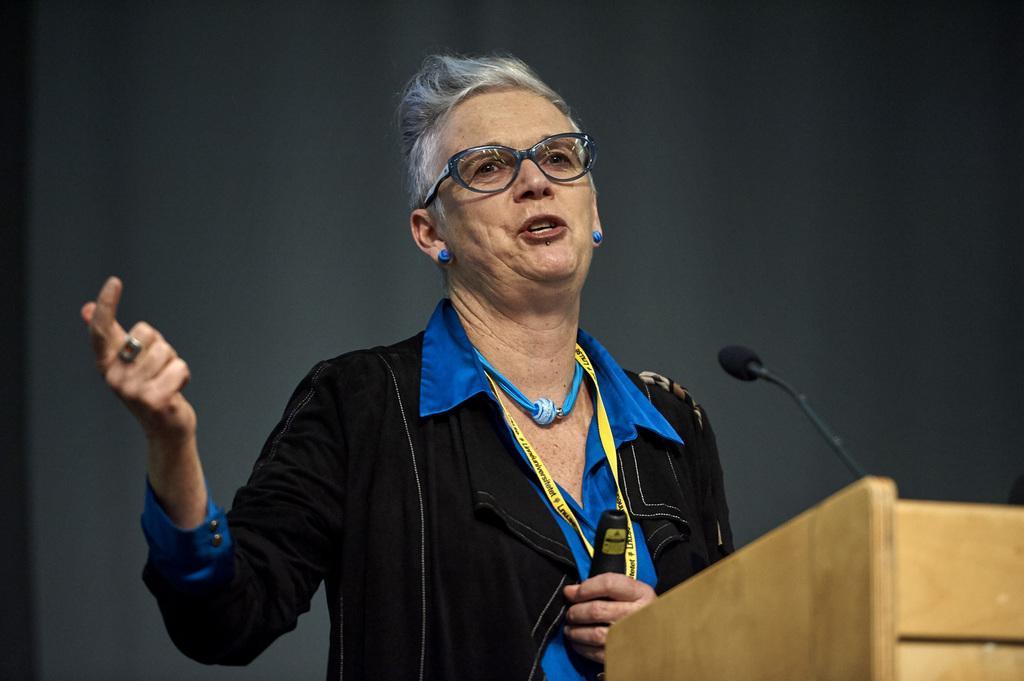Please provide a concise description of this image. In this picture there is an old women wearing black coat with blue shirt and glasses is giving a speech. In the front there is a wooden speech desk with microphone. Behind there is a black background. 